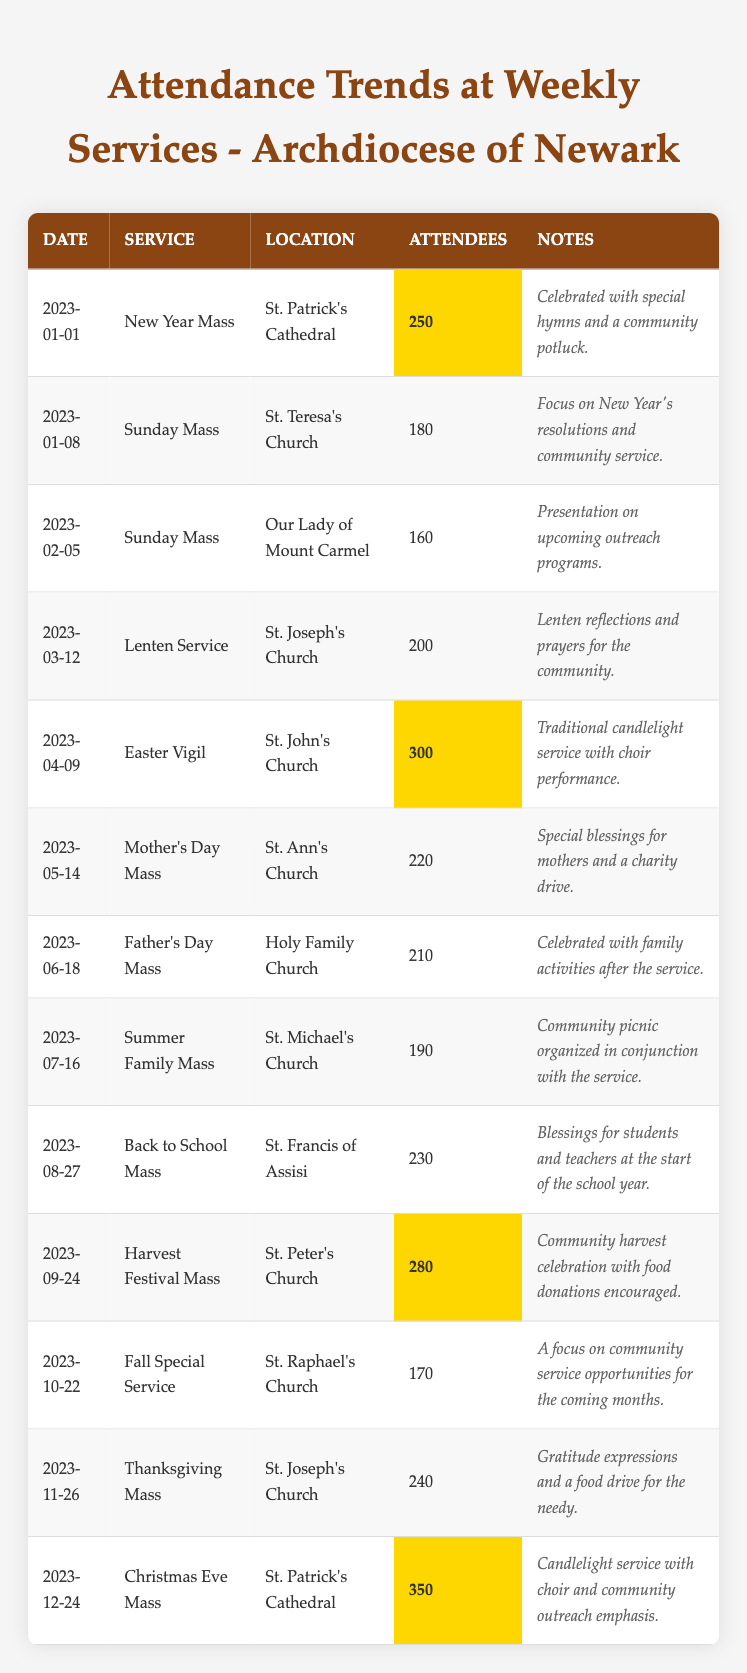What was the attendance at the Easter Vigil service? The table lists the Easter Vigil service on 2023-04-09 at St. John's Church with an attendance of 300.
Answer: 300 Which service had the highest attendance? The highest attendance is listed for the Christmas Eve Mass on 2023-12-24, with 350 attendees at St. Patrick's Cathedral.
Answer: 350 How many attendees were there in total for the Mother's Day and Father's Day Masses combined? The Mother's Day Mass had 220 attendees and the Father's Day Mass had 210 attendees. Adding them together gives 220 + 210 = 430.
Answer: 430 Was there a service that had less than 200 attendees? Yes, the Sunday Mass on 2023-02-05 had 160 attendees, which is below 200.
Answer: Yes Which month had the highest average attendance across its services? January had two services: 250 and 180, averaging (250 + 180)/2 = 215. April had the Easter Vigil with 300, May had 220, June had 210, and July had 190. The highest average attendance comes from December, which only has the Christmas Eve Mass at 350.
Answer: December What was the average attendance for the first quarter of the year (January to March)? The first quarter includes the New Year Mass (250), Sunday Mass (180), and Lenten Service (200). To find the average, sum them: 250 + 180 + 200 = 630; then divide by 3, which gives 630/3 = 210.
Answer: 210 What was the lowest attendance noted in the table? The lowest attendance is on 2023-02-05 at 160 attendees during the Sunday Mass at Our Lady of Mount Carmel.
Answer: 160 Was the Back to School Mass attended by more people than the Summer Family Mass? The Back to School Mass had 230 attendees, while the Summer Family Mass had 190. Since 230 is greater than 190, the Back to School Mass had more attendees.
Answer: Yes How many services were attended by more than 250 people? The Easter Vigil (300), the Back to School Mass (230), and the Christmas Eve Mass (350) were attended by more than 250. Thus, counting these services shows that three services exceeded that threshold.
Answer: 3 What was the change in attendance from the Fall Special Service to the Thanksgiving Mass? The Fall Special Service had 170 attendees and the Thanksgiving Mass had 240 attendees. The change can be calculated as 240 - 170 = 70. Thus, the attendance increased by 70.
Answer: 70 How often did the Church celebrate Mass in January? The table indicates two services in January: the New Year Mass on the 1st and Sunday Mass on the 8th.
Answer: 2 